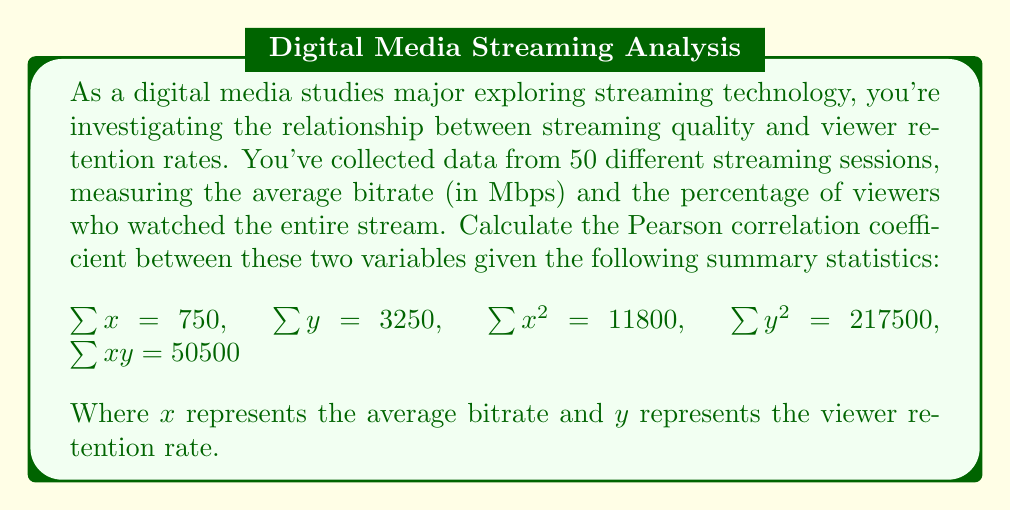Help me with this question. To calculate the Pearson correlation coefficient, we'll use the formula:

$$r = \frac{n\sum xy - \sum x \sum y}{\sqrt{[n\sum x^2 - (\sum x)^2][n\sum y^2 - (\sum y)^2]}}$$

Where:
$n$ = number of pairs of data (50 in this case)
$\sum x$ = sum of all x values
$\sum y$ = sum of all y values
$\sum x^2$ = sum of squares of x values
$\sum y^2$ = sum of squares of y values
$\sum xy$ = sum of products of paired x and y values

Let's substitute the given values:

$n = 50$
$\sum x = 750$
$\sum y = 3250$
$\sum x^2 = 11800$
$\sum y^2 = 217500$
$\sum xy = 50500$

Now, let's calculate step by step:

1. Numerator: $50(50500) - (750)(3250) = 2525000 - 2437500 = 87500$

2. Denominator part 1: $50(11800) - (750)^2 = 590000 - 562500 = 27500$

3. Denominator part 2: $50(217500) - (3250)^2 = 10875000 - 10562500 = 312500$

4. Complete denominator: $\sqrt{(27500)(312500)} = \sqrt{8593750000} = 92702.17$

5. Final calculation: $r = \frac{87500}{92702.17} = 0.9438$
Answer: The Pearson correlation coefficient between streaming quality (average bitrate) and viewer retention rate is approximately 0.9438. 